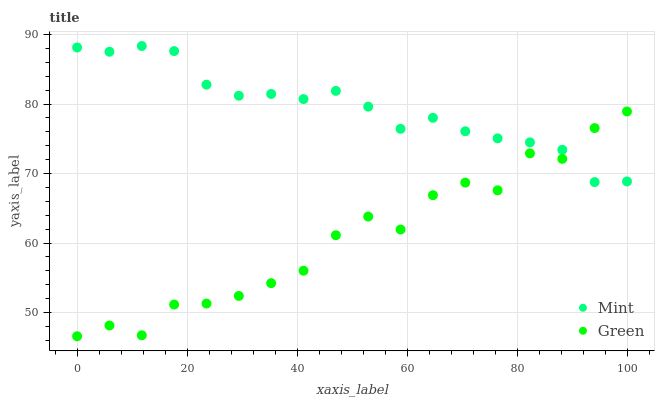Does Green have the minimum area under the curve?
Answer yes or no. Yes. Does Mint have the maximum area under the curve?
Answer yes or no. Yes. Does Mint have the minimum area under the curve?
Answer yes or no. No. Is Mint the smoothest?
Answer yes or no. Yes. Is Green the roughest?
Answer yes or no. Yes. Is Mint the roughest?
Answer yes or no. No. Does Green have the lowest value?
Answer yes or no. Yes. Does Mint have the lowest value?
Answer yes or no. No. Does Mint have the highest value?
Answer yes or no. Yes. Does Green intersect Mint?
Answer yes or no. Yes. Is Green less than Mint?
Answer yes or no. No. Is Green greater than Mint?
Answer yes or no. No. 